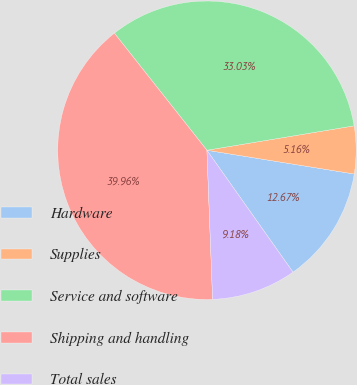Convert chart to OTSL. <chart><loc_0><loc_0><loc_500><loc_500><pie_chart><fcel>Hardware<fcel>Supplies<fcel>Service and software<fcel>Shipping and handling<fcel>Total sales<nl><fcel>12.67%<fcel>5.16%<fcel>33.03%<fcel>39.96%<fcel>9.18%<nl></chart> 